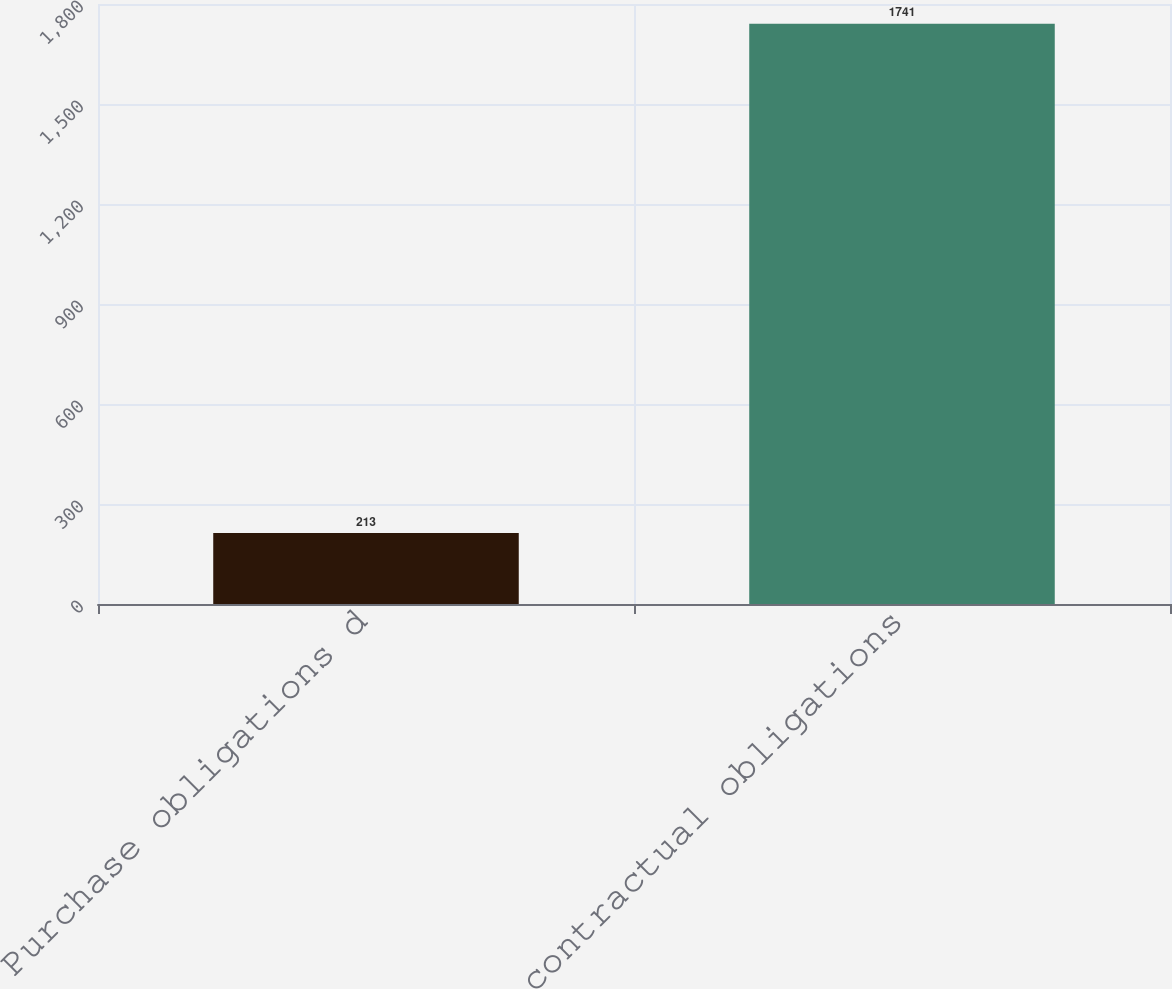Convert chart. <chart><loc_0><loc_0><loc_500><loc_500><bar_chart><fcel>Purchase obligations d<fcel>Total contractual obligations<nl><fcel>213<fcel>1741<nl></chart> 